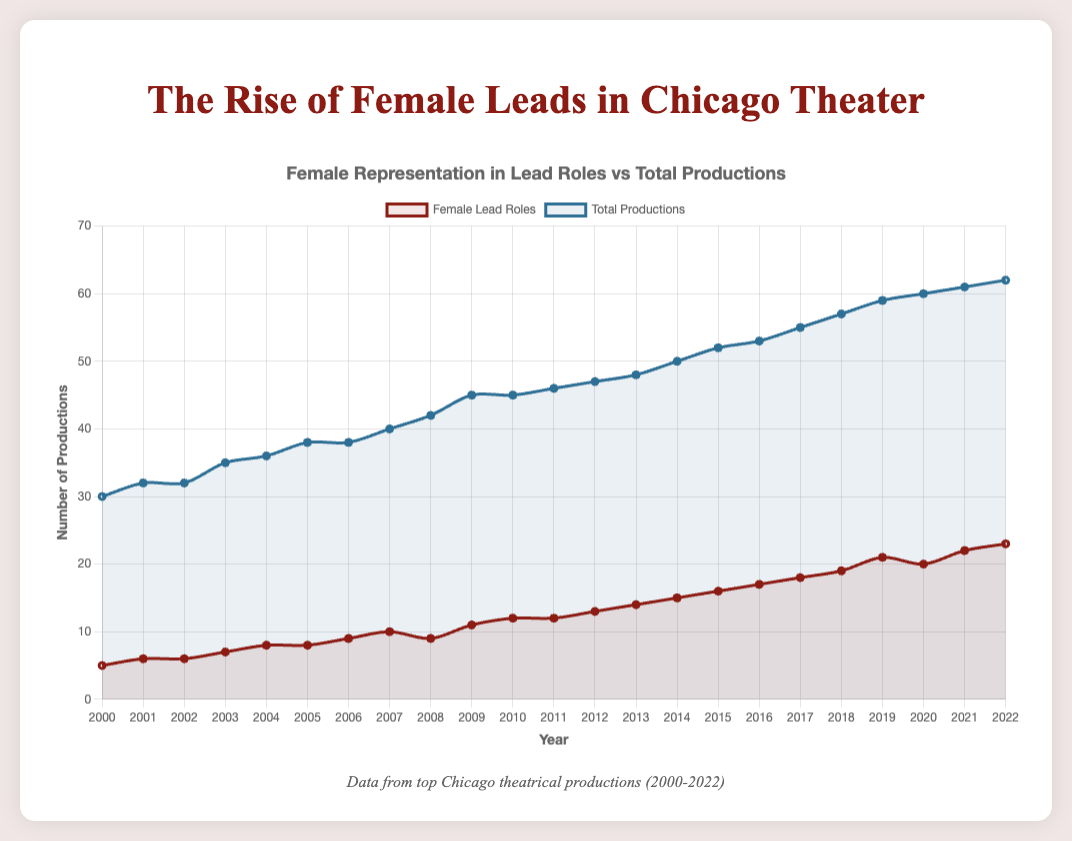What is the general trend in the number of female lead roles from 2000 to 2022? The line representing female lead roles shows a steady increase over time, starting from 5 in 2000 and reaching 23 in 2022, indicating a positive trend.
Answer: Increasing In which year did the number of female lead roles and total productions both reach their peak? By observing the two lines, the highest point for both female lead roles and total productions occurs in 2022, with female lead roles at 23 and total productions at 62.
Answer: 2022 How many more female lead roles were there in 2019 compared to 2009? In 2009, there were 11 female lead roles, and in 2019, there were 21. The difference is calculated as 21 - 11.
Answer: 10 What is the average number of female lead roles from 2000 to 2022? The sum of female lead roles from 2000 to 2022 is 5 + 6 + 6 + 7 + 8 + 8 + 9 + 10 + 9 + 11 + 12 + 12 + 13 + 14 + 15 + 16 + 17 + 18 + 19 + 21 + 20 + 22 + 23 = 320. There are 23 years, so the average is 320 / 23.
Answer: 13.91 Which year has the highest increase in female lead roles compared to the previous year? By examining the differences between consecutive years: 2001(1), 2002(0), 2003(1), 2004(1), 2005(0), 2006(1), 2007(1), 2008(-1), 2009(2), 2010(1), 2011(0), 2012(1), 2013(1), 2014(1), 2015(1), 2016(1), 2017(1), 2018(1), 2019(2), 2020(-1), 2021(2), 2022(1). The highest increase is in 2021 with an increase of 2.
Answer: 2021 What visual attribute best represents the comparison between female lead roles and total productions? The two different colored lines in the chart show female lead roles in red and total productions in blue, helping to visually compare the figures.
Answer: Colored lines Were there any years where the number of female lead roles decreased compared to the previous year? If so, which year(s)? Comparing the data points year by year, the number of female lead roles decreased from 10 to 9 in 2008 and from 21 to 20 in 2020.
Answer: 2008, 2020 In which year did the percentage of female lead roles relative to total productions first exceed 30%? Calculate the percentage by dividing female lead roles by total productions and multiplying by 100. In 2009, the first percentage above 30% is 11/45 * 100 ≈ 24.44%. In 2010, it is 12/45 * 100 ≈ 26.67%. Continue this until 2015, where 16/52 * 100 ≈ 30.77%. Therefore, 2015 is the first year this percentage is exceeded.
Answer: 2015 